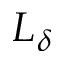<formula> <loc_0><loc_0><loc_500><loc_500>L _ { \delta }</formula> 